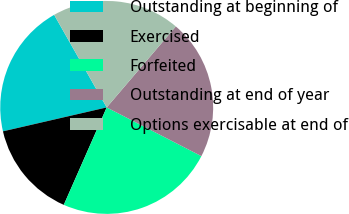<chart> <loc_0><loc_0><loc_500><loc_500><pie_chart><fcel>Outstanding at beginning of<fcel>Exercised<fcel>Forfeited<fcel>Outstanding at end of year<fcel>Options exercisable at end of<nl><fcel>20.39%<fcel>14.79%<fcel>24.04%<fcel>21.32%<fcel>19.46%<nl></chart> 